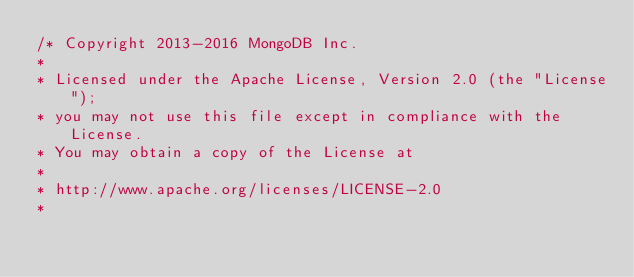Convert code to text. <code><loc_0><loc_0><loc_500><loc_500><_C#_>/* Copyright 2013-2016 MongoDB Inc.
*
* Licensed under the Apache License, Version 2.0 (the "License");
* you may not use this file except in compliance with the License.
* You may obtain a copy of the License at
*
* http://www.apache.org/licenses/LICENSE-2.0
*</code> 